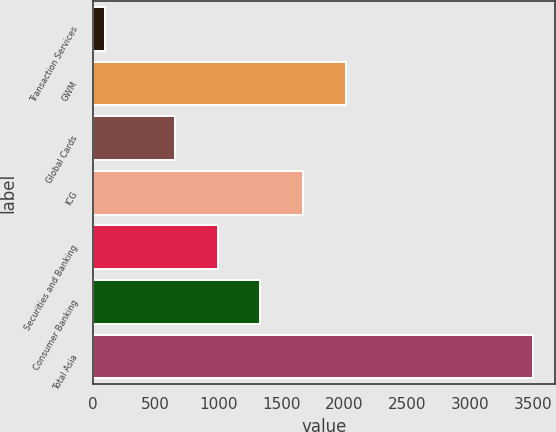<chart> <loc_0><loc_0><loc_500><loc_500><bar_chart><fcel>Transaction Services<fcel>GWM<fcel>Global Cards<fcel>ICG<fcel>Securities and Banking<fcel>Consumer Banking<fcel>Total Asia<nl><fcel>99<fcel>2012.4<fcel>652<fcel>1672.3<fcel>992.1<fcel>1332.2<fcel>3500<nl></chart> 